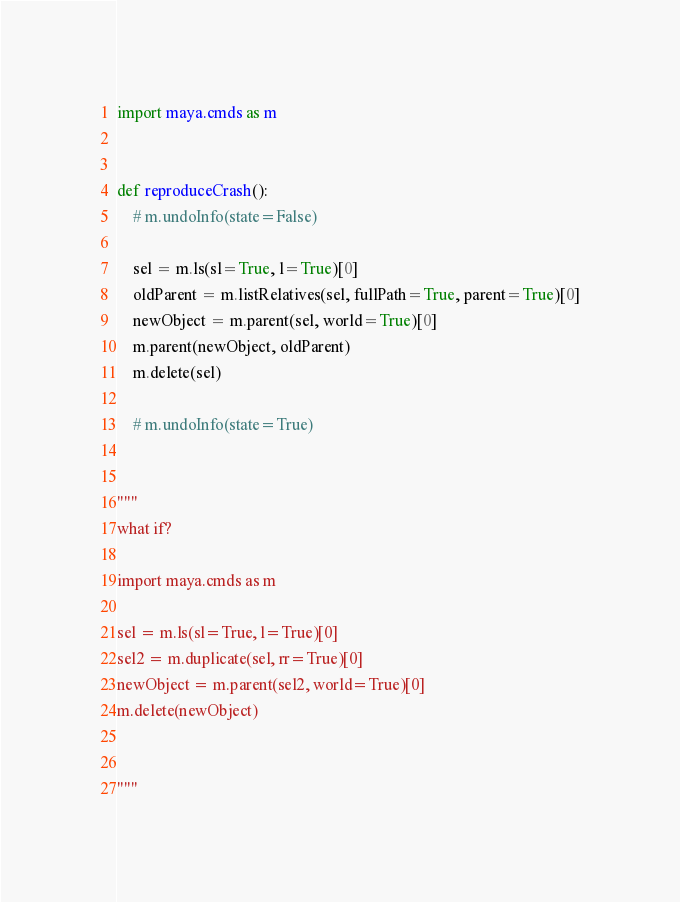Convert code to text. <code><loc_0><loc_0><loc_500><loc_500><_Python_>import maya.cmds as m


def reproduceCrash():
    # m.undoInfo(state=False)

    sel = m.ls(sl=True, l=True)[0]
    oldParent = m.listRelatives(sel, fullPath=True, parent=True)[0]
    newObject = m.parent(sel, world=True)[0]
    m.parent(newObject, oldParent)
    m.delete(sel)

    # m.undoInfo(state=True)


"""
what if?

import maya.cmds as m

sel = m.ls(sl=True, l=True)[0]
sel2 = m.duplicate(sel, rr=True)[0]
newObject = m.parent(sel2, world=True)[0]
m.delete(newObject)


"""</code> 